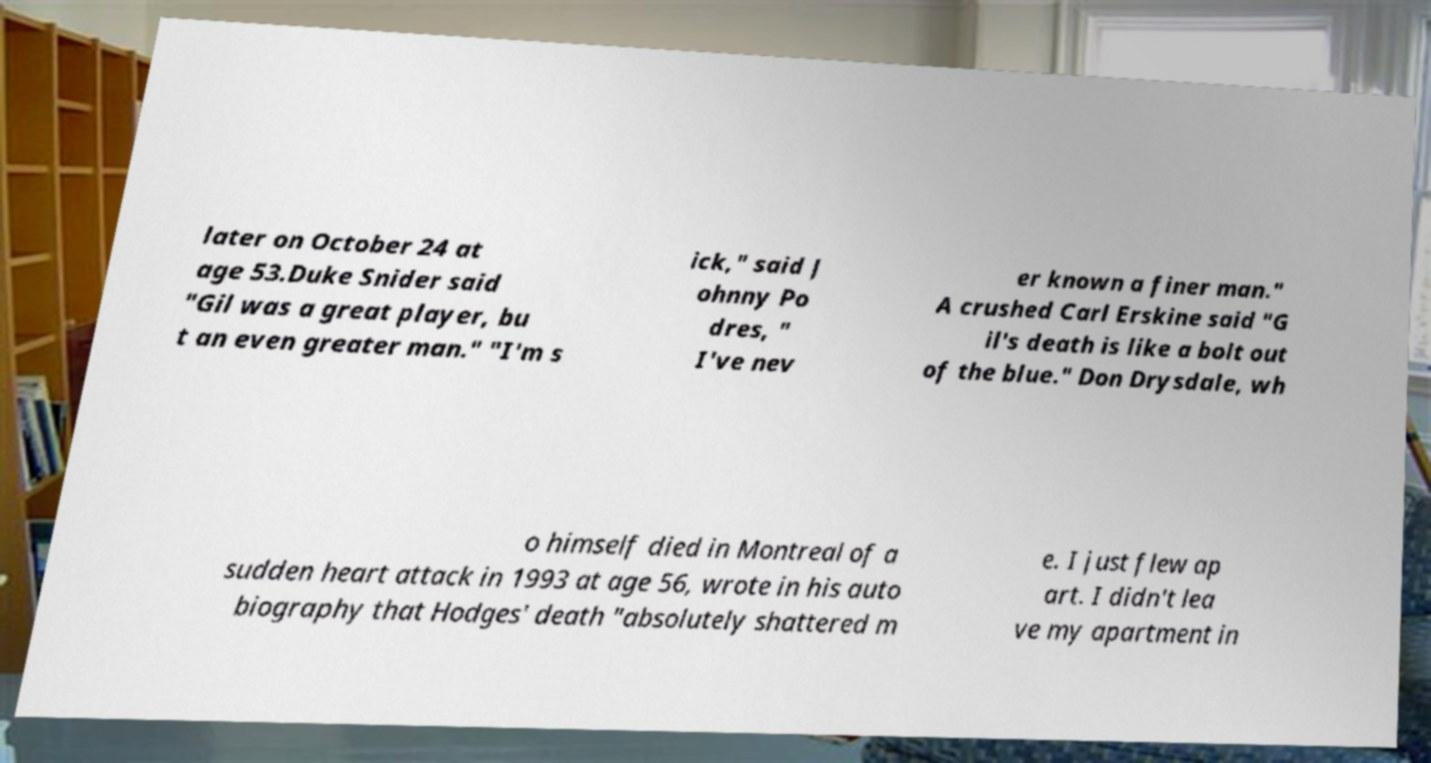I need the written content from this picture converted into text. Can you do that? later on October 24 at age 53.Duke Snider said "Gil was a great player, bu t an even greater man." "I'm s ick," said J ohnny Po dres, " I've nev er known a finer man." A crushed Carl Erskine said "G il's death is like a bolt out of the blue." Don Drysdale, wh o himself died in Montreal of a sudden heart attack in 1993 at age 56, wrote in his auto biography that Hodges' death "absolutely shattered m e. I just flew ap art. I didn't lea ve my apartment in 